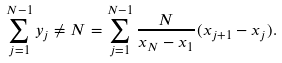Convert formula to latex. <formula><loc_0><loc_0><loc_500><loc_500>\sum _ { j = 1 } ^ { N - 1 } y _ { j } \neq N = \sum _ { j = 1 } ^ { N - 1 } \frac { N } { x _ { N } - x _ { 1 } } ( x _ { j + 1 } - x _ { j } ) .</formula> 